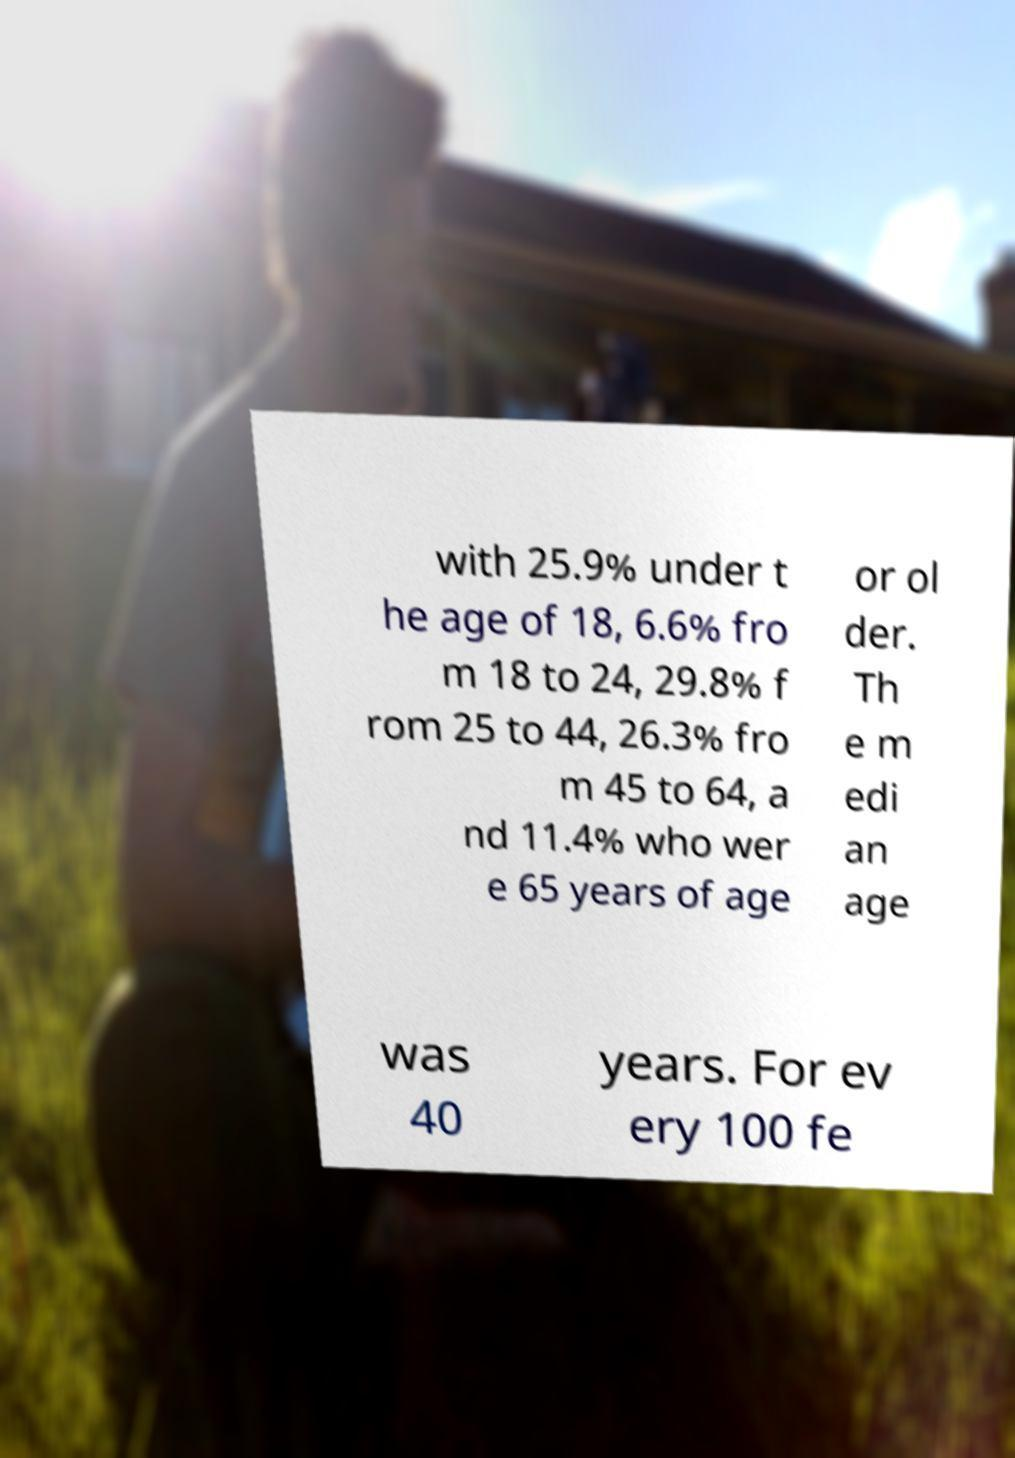For documentation purposes, I need the text within this image transcribed. Could you provide that? with 25.9% under t he age of 18, 6.6% fro m 18 to 24, 29.8% f rom 25 to 44, 26.3% fro m 45 to 64, a nd 11.4% who wer e 65 years of age or ol der. Th e m edi an age was 40 years. For ev ery 100 fe 